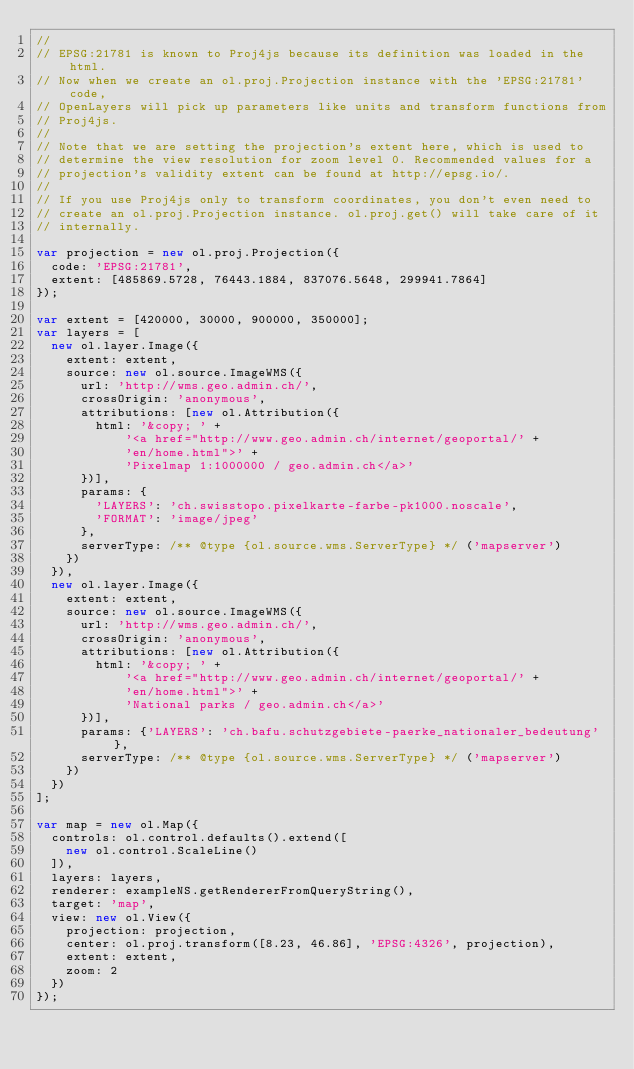<code> <loc_0><loc_0><loc_500><loc_500><_JavaScript_>//
// EPSG:21781 is known to Proj4js because its definition was loaded in the html.
// Now when we create an ol.proj.Projection instance with the 'EPSG:21781' code,
// OpenLayers will pick up parameters like units and transform functions from
// Proj4js.
//
// Note that we are setting the projection's extent here, which is used to
// determine the view resolution for zoom level 0. Recommended values for a
// projection's validity extent can be found at http://epsg.io/.
//
// If you use Proj4js only to transform coordinates, you don't even need to
// create an ol.proj.Projection instance. ol.proj.get() will take care of it
// internally.

var projection = new ol.proj.Projection({
  code: 'EPSG:21781',
  extent: [485869.5728, 76443.1884, 837076.5648, 299941.7864]
});

var extent = [420000, 30000, 900000, 350000];
var layers = [
  new ol.layer.Image({
    extent: extent,
    source: new ol.source.ImageWMS({
      url: 'http://wms.geo.admin.ch/',
      crossOrigin: 'anonymous',
      attributions: [new ol.Attribution({
        html: '&copy; ' +
            '<a href="http://www.geo.admin.ch/internet/geoportal/' +
            'en/home.html">' +
            'Pixelmap 1:1000000 / geo.admin.ch</a>'
      })],
      params: {
        'LAYERS': 'ch.swisstopo.pixelkarte-farbe-pk1000.noscale',
        'FORMAT': 'image/jpeg'
      },
      serverType: /** @type {ol.source.wms.ServerType} */ ('mapserver')
    })
  }),
  new ol.layer.Image({
    extent: extent,
    source: new ol.source.ImageWMS({
      url: 'http://wms.geo.admin.ch/',
      crossOrigin: 'anonymous',
      attributions: [new ol.Attribution({
        html: '&copy; ' +
            '<a href="http://www.geo.admin.ch/internet/geoportal/' +
            'en/home.html">' +
            'National parks / geo.admin.ch</a>'
      })],
      params: {'LAYERS': 'ch.bafu.schutzgebiete-paerke_nationaler_bedeutung'},
      serverType: /** @type {ol.source.wms.ServerType} */ ('mapserver')
    })
  })
];

var map = new ol.Map({
  controls: ol.control.defaults().extend([
    new ol.control.ScaleLine()
  ]),
  layers: layers,
  renderer: exampleNS.getRendererFromQueryString(),
  target: 'map',
  view: new ol.View({
    projection: projection,
    center: ol.proj.transform([8.23, 46.86], 'EPSG:4326', projection),
    extent: extent,
    zoom: 2
  })
});
</code> 